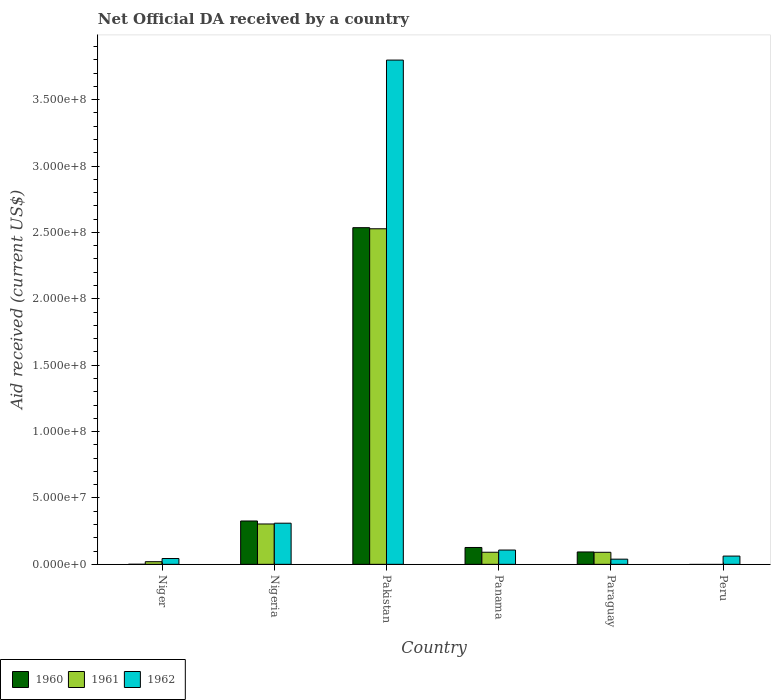How many different coloured bars are there?
Ensure brevity in your answer.  3. Are the number of bars on each tick of the X-axis equal?
Your response must be concise. No. How many bars are there on the 3rd tick from the right?
Provide a succinct answer. 3. What is the label of the 1st group of bars from the left?
Your answer should be compact. Niger. In how many cases, is the number of bars for a given country not equal to the number of legend labels?
Provide a succinct answer. 1. What is the net official development assistance aid received in 1962 in Paraguay?
Your answer should be very brief. 3.89e+06. Across all countries, what is the maximum net official development assistance aid received in 1961?
Provide a succinct answer. 2.53e+08. In which country was the net official development assistance aid received in 1960 maximum?
Provide a succinct answer. Pakistan. What is the total net official development assistance aid received in 1960 in the graph?
Offer a terse response. 3.08e+08. What is the difference between the net official development assistance aid received in 1962 in Niger and that in Peru?
Offer a very short reply. -1.83e+06. What is the difference between the net official development assistance aid received in 1961 in Pakistan and the net official development assistance aid received in 1960 in Peru?
Offer a very short reply. 2.53e+08. What is the average net official development assistance aid received in 1960 per country?
Make the answer very short. 5.14e+07. What is the difference between the net official development assistance aid received of/in 1961 and net official development assistance aid received of/in 1962 in Pakistan?
Offer a terse response. -1.27e+08. In how many countries, is the net official development assistance aid received in 1961 greater than 350000000 US$?
Your response must be concise. 0. What is the ratio of the net official development assistance aid received in 1960 in Nigeria to that in Panama?
Your answer should be compact. 2.57. Is the difference between the net official development assistance aid received in 1961 in Nigeria and Pakistan greater than the difference between the net official development assistance aid received in 1962 in Nigeria and Pakistan?
Offer a very short reply. Yes. What is the difference between the highest and the second highest net official development assistance aid received in 1960?
Keep it short and to the point. 2.21e+08. What is the difference between the highest and the lowest net official development assistance aid received in 1961?
Provide a short and direct response. 2.53e+08. In how many countries, is the net official development assistance aid received in 1960 greater than the average net official development assistance aid received in 1960 taken over all countries?
Your answer should be compact. 1. Is the sum of the net official development assistance aid received in 1962 in Panama and Paraguay greater than the maximum net official development assistance aid received in 1961 across all countries?
Your answer should be very brief. No. How many countries are there in the graph?
Offer a very short reply. 6. Are the values on the major ticks of Y-axis written in scientific E-notation?
Provide a short and direct response. Yes. Does the graph contain any zero values?
Your answer should be very brief. Yes. Does the graph contain grids?
Your response must be concise. No. How many legend labels are there?
Offer a terse response. 3. What is the title of the graph?
Offer a terse response. Net Official DA received by a country. Does "1963" appear as one of the legend labels in the graph?
Make the answer very short. No. What is the label or title of the X-axis?
Give a very brief answer. Country. What is the label or title of the Y-axis?
Your response must be concise. Aid received (current US$). What is the Aid received (current US$) in 1961 in Niger?
Keep it short and to the point. 1.99e+06. What is the Aid received (current US$) in 1962 in Niger?
Your response must be concise. 4.38e+06. What is the Aid received (current US$) in 1960 in Nigeria?
Provide a short and direct response. 3.26e+07. What is the Aid received (current US$) in 1961 in Nigeria?
Offer a terse response. 3.04e+07. What is the Aid received (current US$) in 1962 in Nigeria?
Ensure brevity in your answer.  3.10e+07. What is the Aid received (current US$) in 1960 in Pakistan?
Offer a terse response. 2.54e+08. What is the Aid received (current US$) in 1961 in Pakistan?
Provide a succinct answer. 2.53e+08. What is the Aid received (current US$) in 1962 in Pakistan?
Offer a very short reply. 3.80e+08. What is the Aid received (current US$) in 1960 in Panama?
Your answer should be compact. 1.27e+07. What is the Aid received (current US$) in 1961 in Panama?
Provide a short and direct response. 9.11e+06. What is the Aid received (current US$) in 1962 in Panama?
Make the answer very short. 1.08e+07. What is the Aid received (current US$) of 1960 in Paraguay?
Provide a short and direct response. 9.32e+06. What is the Aid received (current US$) of 1961 in Paraguay?
Your response must be concise. 9.07e+06. What is the Aid received (current US$) of 1962 in Paraguay?
Ensure brevity in your answer.  3.89e+06. What is the Aid received (current US$) in 1961 in Peru?
Make the answer very short. 0. What is the Aid received (current US$) in 1962 in Peru?
Offer a very short reply. 6.21e+06. Across all countries, what is the maximum Aid received (current US$) in 1960?
Provide a short and direct response. 2.54e+08. Across all countries, what is the maximum Aid received (current US$) of 1961?
Provide a succinct answer. 2.53e+08. Across all countries, what is the maximum Aid received (current US$) of 1962?
Your answer should be very brief. 3.80e+08. Across all countries, what is the minimum Aid received (current US$) of 1960?
Make the answer very short. 0. Across all countries, what is the minimum Aid received (current US$) in 1962?
Give a very brief answer. 3.89e+06. What is the total Aid received (current US$) in 1960 in the graph?
Keep it short and to the point. 3.08e+08. What is the total Aid received (current US$) in 1961 in the graph?
Offer a very short reply. 3.03e+08. What is the total Aid received (current US$) of 1962 in the graph?
Give a very brief answer. 4.36e+08. What is the difference between the Aid received (current US$) of 1960 in Niger and that in Nigeria?
Keep it short and to the point. -3.26e+07. What is the difference between the Aid received (current US$) of 1961 in Niger and that in Nigeria?
Offer a terse response. -2.84e+07. What is the difference between the Aid received (current US$) in 1962 in Niger and that in Nigeria?
Offer a very short reply. -2.66e+07. What is the difference between the Aid received (current US$) in 1960 in Niger and that in Pakistan?
Provide a short and direct response. -2.54e+08. What is the difference between the Aid received (current US$) of 1961 in Niger and that in Pakistan?
Offer a very short reply. -2.51e+08. What is the difference between the Aid received (current US$) in 1962 in Niger and that in Pakistan?
Offer a terse response. -3.75e+08. What is the difference between the Aid received (current US$) of 1960 in Niger and that in Panama?
Make the answer very short. -1.26e+07. What is the difference between the Aid received (current US$) in 1961 in Niger and that in Panama?
Provide a succinct answer. -7.12e+06. What is the difference between the Aid received (current US$) of 1962 in Niger and that in Panama?
Provide a short and direct response. -6.38e+06. What is the difference between the Aid received (current US$) of 1960 in Niger and that in Paraguay?
Provide a short and direct response. -9.28e+06. What is the difference between the Aid received (current US$) of 1961 in Niger and that in Paraguay?
Offer a very short reply. -7.08e+06. What is the difference between the Aid received (current US$) of 1962 in Niger and that in Paraguay?
Give a very brief answer. 4.90e+05. What is the difference between the Aid received (current US$) in 1962 in Niger and that in Peru?
Provide a short and direct response. -1.83e+06. What is the difference between the Aid received (current US$) of 1960 in Nigeria and that in Pakistan?
Provide a succinct answer. -2.21e+08. What is the difference between the Aid received (current US$) in 1961 in Nigeria and that in Pakistan?
Offer a terse response. -2.22e+08. What is the difference between the Aid received (current US$) in 1962 in Nigeria and that in Pakistan?
Offer a terse response. -3.49e+08. What is the difference between the Aid received (current US$) of 1960 in Nigeria and that in Panama?
Your answer should be compact. 2.00e+07. What is the difference between the Aid received (current US$) of 1961 in Nigeria and that in Panama?
Give a very brief answer. 2.13e+07. What is the difference between the Aid received (current US$) of 1962 in Nigeria and that in Panama?
Give a very brief answer. 2.02e+07. What is the difference between the Aid received (current US$) in 1960 in Nigeria and that in Paraguay?
Offer a terse response. 2.33e+07. What is the difference between the Aid received (current US$) in 1961 in Nigeria and that in Paraguay?
Provide a short and direct response. 2.13e+07. What is the difference between the Aid received (current US$) of 1962 in Nigeria and that in Paraguay?
Ensure brevity in your answer.  2.71e+07. What is the difference between the Aid received (current US$) of 1962 in Nigeria and that in Peru?
Ensure brevity in your answer.  2.48e+07. What is the difference between the Aid received (current US$) of 1960 in Pakistan and that in Panama?
Offer a very short reply. 2.41e+08. What is the difference between the Aid received (current US$) in 1961 in Pakistan and that in Panama?
Make the answer very short. 2.44e+08. What is the difference between the Aid received (current US$) of 1962 in Pakistan and that in Panama?
Give a very brief answer. 3.69e+08. What is the difference between the Aid received (current US$) in 1960 in Pakistan and that in Paraguay?
Provide a short and direct response. 2.44e+08. What is the difference between the Aid received (current US$) of 1961 in Pakistan and that in Paraguay?
Keep it short and to the point. 2.44e+08. What is the difference between the Aid received (current US$) of 1962 in Pakistan and that in Paraguay?
Your answer should be compact. 3.76e+08. What is the difference between the Aid received (current US$) of 1962 in Pakistan and that in Peru?
Offer a terse response. 3.74e+08. What is the difference between the Aid received (current US$) of 1960 in Panama and that in Paraguay?
Make the answer very short. 3.37e+06. What is the difference between the Aid received (current US$) of 1961 in Panama and that in Paraguay?
Provide a short and direct response. 4.00e+04. What is the difference between the Aid received (current US$) of 1962 in Panama and that in Paraguay?
Your answer should be compact. 6.87e+06. What is the difference between the Aid received (current US$) in 1962 in Panama and that in Peru?
Your answer should be very brief. 4.55e+06. What is the difference between the Aid received (current US$) in 1962 in Paraguay and that in Peru?
Give a very brief answer. -2.32e+06. What is the difference between the Aid received (current US$) of 1960 in Niger and the Aid received (current US$) of 1961 in Nigeria?
Your answer should be compact. -3.04e+07. What is the difference between the Aid received (current US$) in 1960 in Niger and the Aid received (current US$) in 1962 in Nigeria?
Your answer should be very brief. -3.09e+07. What is the difference between the Aid received (current US$) of 1961 in Niger and the Aid received (current US$) of 1962 in Nigeria?
Your response must be concise. -2.90e+07. What is the difference between the Aid received (current US$) of 1960 in Niger and the Aid received (current US$) of 1961 in Pakistan?
Give a very brief answer. -2.53e+08. What is the difference between the Aid received (current US$) in 1960 in Niger and the Aid received (current US$) in 1962 in Pakistan?
Offer a very short reply. -3.80e+08. What is the difference between the Aid received (current US$) in 1961 in Niger and the Aid received (current US$) in 1962 in Pakistan?
Your answer should be very brief. -3.78e+08. What is the difference between the Aid received (current US$) in 1960 in Niger and the Aid received (current US$) in 1961 in Panama?
Your answer should be very brief. -9.07e+06. What is the difference between the Aid received (current US$) of 1960 in Niger and the Aid received (current US$) of 1962 in Panama?
Give a very brief answer. -1.07e+07. What is the difference between the Aid received (current US$) of 1961 in Niger and the Aid received (current US$) of 1962 in Panama?
Your response must be concise. -8.77e+06. What is the difference between the Aid received (current US$) of 1960 in Niger and the Aid received (current US$) of 1961 in Paraguay?
Keep it short and to the point. -9.03e+06. What is the difference between the Aid received (current US$) in 1960 in Niger and the Aid received (current US$) in 1962 in Paraguay?
Provide a short and direct response. -3.85e+06. What is the difference between the Aid received (current US$) of 1961 in Niger and the Aid received (current US$) of 1962 in Paraguay?
Your answer should be very brief. -1.90e+06. What is the difference between the Aid received (current US$) in 1960 in Niger and the Aid received (current US$) in 1962 in Peru?
Your response must be concise. -6.17e+06. What is the difference between the Aid received (current US$) of 1961 in Niger and the Aid received (current US$) of 1962 in Peru?
Make the answer very short. -4.22e+06. What is the difference between the Aid received (current US$) of 1960 in Nigeria and the Aid received (current US$) of 1961 in Pakistan?
Your response must be concise. -2.20e+08. What is the difference between the Aid received (current US$) in 1960 in Nigeria and the Aid received (current US$) in 1962 in Pakistan?
Offer a terse response. -3.47e+08. What is the difference between the Aid received (current US$) in 1961 in Nigeria and the Aid received (current US$) in 1962 in Pakistan?
Offer a very short reply. -3.49e+08. What is the difference between the Aid received (current US$) in 1960 in Nigeria and the Aid received (current US$) in 1961 in Panama?
Keep it short and to the point. 2.35e+07. What is the difference between the Aid received (current US$) of 1960 in Nigeria and the Aid received (current US$) of 1962 in Panama?
Provide a succinct answer. 2.19e+07. What is the difference between the Aid received (current US$) in 1961 in Nigeria and the Aid received (current US$) in 1962 in Panama?
Your answer should be very brief. 1.96e+07. What is the difference between the Aid received (current US$) of 1960 in Nigeria and the Aid received (current US$) of 1961 in Paraguay?
Make the answer very short. 2.36e+07. What is the difference between the Aid received (current US$) of 1960 in Nigeria and the Aid received (current US$) of 1962 in Paraguay?
Offer a terse response. 2.88e+07. What is the difference between the Aid received (current US$) of 1961 in Nigeria and the Aid received (current US$) of 1962 in Paraguay?
Offer a very short reply. 2.65e+07. What is the difference between the Aid received (current US$) of 1960 in Nigeria and the Aid received (current US$) of 1962 in Peru?
Offer a terse response. 2.64e+07. What is the difference between the Aid received (current US$) in 1961 in Nigeria and the Aid received (current US$) in 1962 in Peru?
Your answer should be very brief. 2.42e+07. What is the difference between the Aid received (current US$) of 1960 in Pakistan and the Aid received (current US$) of 1961 in Panama?
Ensure brevity in your answer.  2.44e+08. What is the difference between the Aid received (current US$) of 1960 in Pakistan and the Aid received (current US$) of 1962 in Panama?
Provide a short and direct response. 2.43e+08. What is the difference between the Aid received (current US$) in 1961 in Pakistan and the Aid received (current US$) in 1962 in Panama?
Offer a very short reply. 2.42e+08. What is the difference between the Aid received (current US$) of 1960 in Pakistan and the Aid received (current US$) of 1961 in Paraguay?
Your answer should be compact. 2.44e+08. What is the difference between the Aid received (current US$) of 1960 in Pakistan and the Aid received (current US$) of 1962 in Paraguay?
Offer a terse response. 2.50e+08. What is the difference between the Aid received (current US$) of 1961 in Pakistan and the Aid received (current US$) of 1962 in Paraguay?
Your answer should be very brief. 2.49e+08. What is the difference between the Aid received (current US$) of 1960 in Pakistan and the Aid received (current US$) of 1962 in Peru?
Make the answer very short. 2.47e+08. What is the difference between the Aid received (current US$) of 1961 in Pakistan and the Aid received (current US$) of 1962 in Peru?
Provide a short and direct response. 2.47e+08. What is the difference between the Aid received (current US$) in 1960 in Panama and the Aid received (current US$) in 1961 in Paraguay?
Your response must be concise. 3.62e+06. What is the difference between the Aid received (current US$) in 1960 in Panama and the Aid received (current US$) in 1962 in Paraguay?
Your answer should be very brief. 8.80e+06. What is the difference between the Aid received (current US$) in 1961 in Panama and the Aid received (current US$) in 1962 in Paraguay?
Offer a very short reply. 5.22e+06. What is the difference between the Aid received (current US$) of 1960 in Panama and the Aid received (current US$) of 1962 in Peru?
Offer a very short reply. 6.48e+06. What is the difference between the Aid received (current US$) in 1961 in Panama and the Aid received (current US$) in 1962 in Peru?
Ensure brevity in your answer.  2.90e+06. What is the difference between the Aid received (current US$) of 1960 in Paraguay and the Aid received (current US$) of 1962 in Peru?
Ensure brevity in your answer.  3.11e+06. What is the difference between the Aid received (current US$) in 1961 in Paraguay and the Aid received (current US$) in 1962 in Peru?
Your response must be concise. 2.86e+06. What is the average Aid received (current US$) of 1960 per country?
Offer a terse response. 5.14e+07. What is the average Aid received (current US$) in 1961 per country?
Give a very brief answer. 5.06e+07. What is the average Aid received (current US$) of 1962 per country?
Offer a terse response. 7.27e+07. What is the difference between the Aid received (current US$) in 1960 and Aid received (current US$) in 1961 in Niger?
Your answer should be compact. -1.95e+06. What is the difference between the Aid received (current US$) in 1960 and Aid received (current US$) in 1962 in Niger?
Give a very brief answer. -4.34e+06. What is the difference between the Aid received (current US$) in 1961 and Aid received (current US$) in 1962 in Niger?
Your response must be concise. -2.39e+06. What is the difference between the Aid received (current US$) of 1960 and Aid received (current US$) of 1961 in Nigeria?
Make the answer very short. 2.25e+06. What is the difference between the Aid received (current US$) in 1960 and Aid received (current US$) in 1962 in Nigeria?
Your answer should be compact. 1.66e+06. What is the difference between the Aid received (current US$) of 1961 and Aid received (current US$) of 1962 in Nigeria?
Make the answer very short. -5.90e+05. What is the difference between the Aid received (current US$) in 1960 and Aid received (current US$) in 1961 in Pakistan?
Keep it short and to the point. 8.20e+05. What is the difference between the Aid received (current US$) in 1960 and Aid received (current US$) in 1962 in Pakistan?
Provide a succinct answer. -1.26e+08. What is the difference between the Aid received (current US$) in 1961 and Aid received (current US$) in 1962 in Pakistan?
Ensure brevity in your answer.  -1.27e+08. What is the difference between the Aid received (current US$) of 1960 and Aid received (current US$) of 1961 in Panama?
Give a very brief answer. 3.58e+06. What is the difference between the Aid received (current US$) in 1960 and Aid received (current US$) in 1962 in Panama?
Make the answer very short. 1.93e+06. What is the difference between the Aid received (current US$) in 1961 and Aid received (current US$) in 1962 in Panama?
Your response must be concise. -1.65e+06. What is the difference between the Aid received (current US$) in 1960 and Aid received (current US$) in 1962 in Paraguay?
Your answer should be very brief. 5.43e+06. What is the difference between the Aid received (current US$) in 1961 and Aid received (current US$) in 1962 in Paraguay?
Make the answer very short. 5.18e+06. What is the ratio of the Aid received (current US$) of 1960 in Niger to that in Nigeria?
Ensure brevity in your answer.  0. What is the ratio of the Aid received (current US$) in 1961 in Niger to that in Nigeria?
Ensure brevity in your answer.  0.07. What is the ratio of the Aid received (current US$) of 1962 in Niger to that in Nigeria?
Give a very brief answer. 0.14. What is the ratio of the Aid received (current US$) in 1960 in Niger to that in Pakistan?
Your answer should be very brief. 0. What is the ratio of the Aid received (current US$) of 1961 in Niger to that in Pakistan?
Offer a very short reply. 0.01. What is the ratio of the Aid received (current US$) of 1962 in Niger to that in Pakistan?
Make the answer very short. 0.01. What is the ratio of the Aid received (current US$) in 1960 in Niger to that in Panama?
Your response must be concise. 0. What is the ratio of the Aid received (current US$) of 1961 in Niger to that in Panama?
Your response must be concise. 0.22. What is the ratio of the Aid received (current US$) of 1962 in Niger to that in Panama?
Provide a short and direct response. 0.41. What is the ratio of the Aid received (current US$) in 1960 in Niger to that in Paraguay?
Make the answer very short. 0. What is the ratio of the Aid received (current US$) in 1961 in Niger to that in Paraguay?
Offer a very short reply. 0.22. What is the ratio of the Aid received (current US$) in 1962 in Niger to that in Paraguay?
Ensure brevity in your answer.  1.13. What is the ratio of the Aid received (current US$) of 1962 in Niger to that in Peru?
Keep it short and to the point. 0.71. What is the ratio of the Aid received (current US$) of 1960 in Nigeria to that in Pakistan?
Offer a terse response. 0.13. What is the ratio of the Aid received (current US$) in 1961 in Nigeria to that in Pakistan?
Ensure brevity in your answer.  0.12. What is the ratio of the Aid received (current US$) of 1962 in Nigeria to that in Pakistan?
Your answer should be compact. 0.08. What is the ratio of the Aid received (current US$) in 1960 in Nigeria to that in Panama?
Make the answer very short. 2.57. What is the ratio of the Aid received (current US$) in 1961 in Nigeria to that in Panama?
Keep it short and to the point. 3.34. What is the ratio of the Aid received (current US$) of 1962 in Nigeria to that in Panama?
Offer a very short reply. 2.88. What is the ratio of the Aid received (current US$) of 1960 in Nigeria to that in Paraguay?
Offer a terse response. 3.5. What is the ratio of the Aid received (current US$) of 1961 in Nigeria to that in Paraguay?
Your response must be concise. 3.35. What is the ratio of the Aid received (current US$) in 1962 in Nigeria to that in Paraguay?
Your answer should be compact. 7.96. What is the ratio of the Aid received (current US$) in 1962 in Nigeria to that in Peru?
Offer a very short reply. 4.99. What is the ratio of the Aid received (current US$) of 1960 in Pakistan to that in Panama?
Ensure brevity in your answer.  19.98. What is the ratio of the Aid received (current US$) in 1961 in Pakistan to that in Panama?
Your response must be concise. 27.74. What is the ratio of the Aid received (current US$) of 1962 in Pakistan to that in Panama?
Give a very brief answer. 35.3. What is the ratio of the Aid received (current US$) in 1960 in Pakistan to that in Paraguay?
Give a very brief answer. 27.21. What is the ratio of the Aid received (current US$) of 1961 in Pakistan to that in Paraguay?
Ensure brevity in your answer.  27.87. What is the ratio of the Aid received (current US$) in 1962 in Pakistan to that in Paraguay?
Your answer should be very brief. 97.63. What is the ratio of the Aid received (current US$) of 1962 in Pakistan to that in Peru?
Your answer should be compact. 61.16. What is the ratio of the Aid received (current US$) in 1960 in Panama to that in Paraguay?
Offer a very short reply. 1.36. What is the ratio of the Aid received (current US$) of 1961 in Panama to that in Paraguay?
Keep it short and to the point. 1. What is the ratio of the Aid received (current US$) of 1962 in Panama to that in Paraguay?
Your answer should be compact. 2.77. What is the ratio of the Aid received (current US$) in 1962 in Panama to that in Peru?
Your response must be concise. 1.73. What is the ratio of the Aid received (current US$) of 1962 in Paraguay to that in Peru?
Offer a terse response. 0.63. What is the difference between the highest and the second highest Aid received (current US$) in 1960?
Ensure brevity in your answer.  2.21e+08. What is the difference between the highest and the second highest Aid received (current US$) of 1961?
Offer a terse response. 2.22e+08. What is the difference between the highest and the second highest Aid received (current US$) of 1962?
Your answer should be compact. 3.49e+08. What is the difference between the highest and the lowest Aid received (current US$) of 1960?
Your response must be concise. 2.54e+08. What is the difference between the highest and the lowest Aid received (current US$) in 1961?
Keep it short and to the point. 2.53e+08. What is the difference between the highest and the lowest Aid received (current US$) in 1962?
Offer a very short reply. 3.76e+08. 